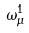<formula> <loc_0><loc_0><loc_500><loc_500>\omega _ { \mu } ^ { 1 }</formula> 